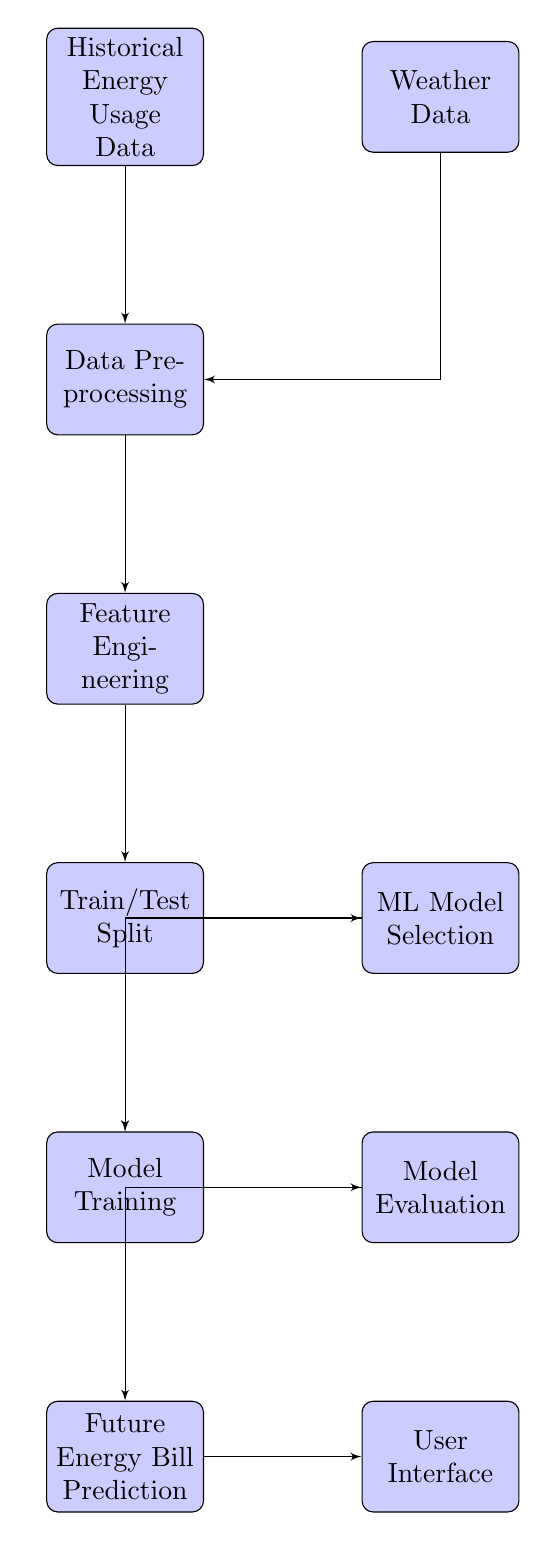What's the total number of blocks in the diagram? The diagram contains 9 blocks, as counted by observing each individually labeled section such as "Historical Energy Usage Data," "Weather Data," and others down to "User Interface."
Answer: 9 What is the last block in the sequence? The last block in the sequence is "User Interface," as it is located at the bottom right after the "Future Energy Bill Prediction," completing the flow of the diagram.
Answer: User Interface Which block comes after "Model Evaluation"? After "Model Evaluation," the next block in the flow is "Future Energy Bill Prediction," indicated by the direction of the arrow pointing from "Model Evaluation."
Answer: Future Energy Bill Prediction How many inputs feed into the "Data Preprocessing" block? There are two inputs feeding into the "Data Preprocessing" block: "Historical Energy Usage Data" and "Weather Data," as shown by the arrows directed toward "Data Preprocessing."
Answer: 2 What is the primary function of the "Feature Engineering" block? The "Feature Engineering" block is primarily responsible for transforming the data by selecting, modifying, or creating features that will help in improving the performance of the machine learning model based on the processed data.
Answer: Transforming data What is the relationship between "Train/Test Split" and "Model Training"? The relationship is that "Train/Test Split" is a prerequisite for "Model Training" as indicated by the direct flow from "Train/Test Split" to the "Model Training" block, showing the sequence of operations.
Answer: Prerequisite Which two blocks are involved in the output prediction phase? The two blocks involved in the output prediction phase are "Train" and "Predict," where "Train" prepares the model and "Predict" uses that model to forecast future energy bills.
Answer: Train, Predict What is the first step in the process illustrated in the diagram? The first step in the process is "Historical Energy Usage Data," which starts the flow by providing essential data for analysis.
Answer: Historical Energy Usage Data Which block has the role of applying a machine learning model? The block with the role of applying a machine learning model is "Model Training," where the selected machine learning algorithms are trained on the input data to learn patterns.
Answer: Model Training 